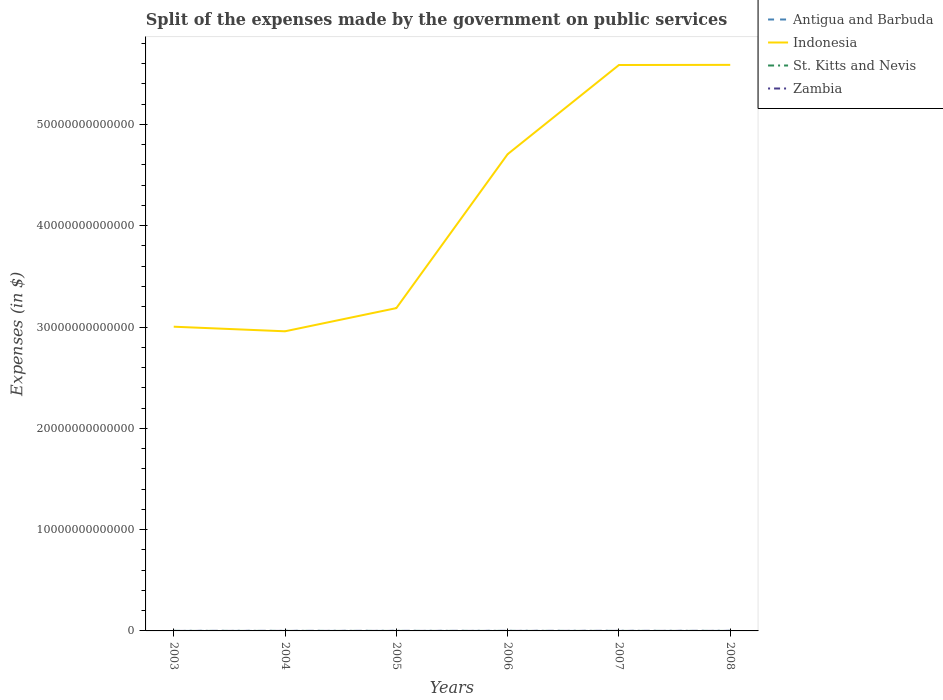Does the line corresponding to Antigua and Barbuda intersect with the line corresponding to Indonesia?
Keep it short and to the point. No. Across all years, what is the maximum expenses made by the government on public services in Antigua and Barbuda?
Provide a succinct answer. 9.59e+07. In which year was the expenses made by the government on public services in Indonesia maximum?
Give a very brief answer. 2004. What is the total expenses made by the government on public services in Antigua and Barbuda in the graph?
Keep it short and to the point. -1.63e+07. What is the difference between the highest and the second highest expenses made by the government on public services in Indonesia?
Your answer should be very brief. 2.63e+13. What is the difference between the highest and the lowest expenses made by the government on public services in Indonesia?
Your answer should be very brief. 3. Is the expenses made by the government on public services in Zambia strictly greater than the expenses made by the government on public services in Indonesia over the years?
Your answer should be very brief. Yes. What is the difference between two consecutive major ticks on the Y-axis?
Offer a very short reply. 1.00e+13. Are the values on the major ticks of Y-axis written in scientific E-notation?
Offer a very short reply. No. Does the graph contain any zero values?
Ensure brevity in your answer.  No. Where does the legend appear in the graph?
Make the answer very short. Top right. How many legend labels are there?
Provide a succinct answer. 4. How are the legend labels stacked?
Give a very brief answer. Vertical. What is the title of the graph?
Make the answer very short. Split of the expenses made by the government on public services. What is the label or title of the X-axis?
Make the answer very short. Years. What is the label or title of the Y-axis?
Your answer should be compact. Expenses (in $). What is the Expenses (in $) in Antigua and Barbuda in 2003?
Offer a terse response. 9.59e+07. What is the Expenses (in $) of Indonesia in 2003?
Give a very brief answer. 3.00e+13. What is the Expenses (in $) in St. Kitts and Nevis in 2003?
Give a very brief answer. 7.90e+07. What is the Expenses (in $) in Zambia in 2003?
Provide a succinct answer. 6.77e+08. What is the Expenses (in $) of Antigua and Barbuda in 2004?
Give a very brief answer. 1.10e+08. What is the Expenses (in $) of Indonesia in 2004?
Your answer should be very brief. 2.96e+13. What is the Expenses (in $) in St. Kitts and Nevis in 2004?
Provide a short and direct response. 9.58e+07. What is the Expenses (in $) of Zambia in 2004?
Provide a succinct answer. 8.90e+08. What is the Expenses (in $) in Antigua and Barbuda in 2005?
Offer a very short reply. 1.11e+08. What is the Expenses (in $) in Indonesia in 2005?
Make the answer very short. 3.19e+13. What is the Expenses (in $) in St. Kitts and Nevis in 2005?
Provide a succinct answer. 1.15e+08. What is the Expenses (in $) in Zambia in 2005?
Your response must be concise. 1.87e+09. What is the Expenses (in $) of Antigua and Barbuda in 2006?
Make the answer very short. 1.26e+08. What is the Expenses (in $) in Indonesia in 2006?
Your answer should be compact. 4.71e+13. What is the Expenses (in $) in St. Kitts and Nevis in 2006?
Make the answer very short. 1.29e+08. What is the Expenses (in $) of Zambia in 2006?
Offer a terse response. 2.12e+09. What is the Expenses (in $) in Antigua and Barbuda in 2007?
Give a very brief answer. 1.48e+08. What is the Expenses (in $) of Indonesia in 2007?
Ensure brevity in your answer.  5.59e+13. What is the Expenses (in $) of St. Kitts and Nevis in 2007?
Make the answer very short. 1.40e+08. What is the Expenses (in $) in Zambia in 2007?
Your answer should be very brief. 3.34e+09. What is the Expenses (in $) in Antigua and Barbuda in 2008?
Provide a short and direct response. 1.85e+08. What is the Expenses (in $) of Indonesia in 2008?
Your answer should be compact. 5.59e+13. What is the Expenses (in $) in St. Kitts and Nevis in 2008?
Keep it short and to the point. 1.37e+08. What is the Expenses (in $) in Zambia in 2008?
Ensure brevity in your answer.  3.00e+09. Across all years, what is the maximum Expenses (in $) of Antigua and Barbuda?
Offer a terse response. 1.85e+08. Across all years, what is the maximum Expenses (in $) of Indonesia?
Provide a succinct answer. 5.59e+13. Across all years, what is the maximum Expenses (in $) in St. Kitts and Nevis?
Your answer should be very brief. 1.40e+08. Across all years, what is the maximum Expenses (in $) in Zambia?
Offer a very short reply. 3.34e+09. Across all years, what is the minimum Expenses (in $) in Antigua and Barbuda?
Provide a succinct answer. 9.59e+07. Across all years, what is the minimum Expenses (in $) of Indonesia?
Give a very brief answer. 2.96e+13. Across all years, what is the minimum Expenses (in $) of St. Kitts and Nevis?
Give a very brief answer. 7.90e+07. Across all years, what is the minimum Expenses (in $) in Zambia?
Provide a short and direct response. 6.77e+08. What is the total Expenses (in $) of Antigua and Barbuda in the graph?
Offer a very short reply. 7.76e+08. What is the total Expenses (in $) in Indonesia in the graph?
Your answer should be very brief. 2.50e+14. What is the total Expenses (in $) of St. Kitts and Nevis in the graph?
Keep it short and to the point. 6.96e+08. What is the total Expenses (in $) in Zambia in the graph?
Provide a succinct answer. 1.19e+1. What is the difference between the Expenses (in $) in Antigua and Barbuda in 2003 and that in 2004?
Keep it short and to the point. -1.40e+07. What is the difference between the Expenses (in $) in Indonesia in 2003 and that in 2004?
Your answer should be compact. 4.54e+11. What is the difference between the Expenses (in $) of St. Kitts and Nevis in 2003 and that in 2004?
Your answer should be very brief. -1.68e+07. What is the difference between the Expenses (in $) of Zambia in 2003 and that in 2004?
Offer a terse response. -2.13e+08. What is the difference between the Expenses (in $) of Antigua and Barbuda in 2003 and that in 2005?
Your answer should be very brief. -1.51e+07. What is the difference between the Expenses (in $) in Indonesia in 2003 and that in 2005?
Offer a terse response. -1.83e+12. What is the difference between the Expenses (in $) of St. Kitts and Nevis in 2003 and that in 2005?
Ensure brevity in your answer.  -3.57e+07. What is the difference between the Expenses (in $) of Zambia in 2003 and that in 2005?
Your response must be concise. -1.20e+09. What is the difference between the Expenses (in $) in Antigua and Barbuda in 2003 and that in 2006?
Offer a terse response. -3.03e+07. What is the difference between the Expenses (in $) in Indonesia in 2003 and that in 2006?
Your answer should be compact. -1.70e+13. What is the difference between the Expenses (in $) in St. Kitts and Nevis in 2003 and that in 2006?
Give a very brief answer. -5.04e+07. What is the difference between the Expenses (in $) in Zambia in 2003 and that in 2006?
Your response must be concise. -1.44e+09. What is the difference between the Expenses (in $) of Antigua and Barbuda in 2003 and that in 2007?
Offer a very short reply. -5.17e+07. What is the difference between the Expenses (in $) of Indonesia in 2003 and that in 2007?
Provide a short and direct response. -2.58e+13. What is the difference between the Expenses (in $) in St. Kitts and Nevis in 2003 and that in 2007?
Provide a succinct answer. -6.14e+07. What is the difference between the Expenses (in $) in Zambia in 2003 and that in 2007?
Give a very brief answer. -2.66e+09. What is the difference between the Expenses (in $) of Antigua and Barbuda in 2003 and that in 2008?
Make the answer very short. -8.91e+07. What is the difference between the Expenses (in $) of Indonesia in 2003 and that in 2008?
Make the answer very short. -2.58e+13. What is the difference between the Expenses (in $) of St. Kitts and Nevis in 2003 and that in 2008?
Your response must be concise. -5.82e+07. What is the difference between the Expenses (in $) of Zambia in 2003 and that in 2008?
Your response must be concise. -2.32e+09. What is the difference between the Expenses (in $) of Antigua and Barbuda in 2004 and that in 2005?
Make the answer very short. -1.10e+06. What is the difference between the Expenses (in $) in Indonesia in 2004 and that in 2005?
Make the answer very short. -2.29e+12. What is the difference between the Expenses (in $) of St. Kitts and Nevis in 2004 and that in 2005?
Make the answer very short. -1.89e+07. What is the difference between the Expenses (in $) of Zambia in 2004 and that in 2005?
Your answer should be compact. -9.83e+08. What is the difference between the Expenses (in $) in Antigua and Barbuda in 2004 and that in 2006?
Ensure brevity in your answer.  -1.63e+07. What is the difference between the Expenses (in $) in Indonesia in 2004 and that in 2006?
Offer a terse response. -1.75e+13. What is the difference between the Expenses (in $) of St. Kitts and Nevis in 2004 and that in 2006?
Make the answer very short. -3.36e+07. What is the difference between the Expenses (in $) in Zambia in 2004 and that in 2006?
Your response must be concise. -1.23e+09. What is the difference between the Expenses (in $) in Antigua and Barbuda in 2004 and that in 2007?
Ensure brevity in your answer.  -3.77e+07. What is the difference between the Expenses (in $) of Indonesia in 2004 and that in 2007?
Provide a succinct answer. -2.63e+13. What is the difference between the Expenses (in $) in St. Kitts and Nevis in 2004 and that in 2007?
Provide a short and direct response. -4.46e+07. What is the difference between the Expenses (in $) of Zambia in 2004 and that in 2007?
Ensure brevity in your answer.  -2.45e+09. What is the difference between the Expenses (in $) of Antigua and Barbuda in 2004 and that in 2008?
Ensure brevity in your answer.  -7.51e+07. What is the difference between the Expenses (in $) in Indonesia in 2004 and that in 2008?
Provide a succinct answer. -2.63e+13. What is the difference between the Expenses (in $) in St. Kitts and Nevis in 2004 and that in 2008?
Provide a succinct answer. -4.14e+07. What is the difference between the Expenses (in $) of Zambia in 2004 and that in 2008?
Keep it short and to the point. -2.11e+09. What is the difference between the Expenses (in $) in Antigua and Barbuda in 2005 and that in 2006?
Give a very brief answer. -1.52e+07. What is the difference between the Expenses (in $) of Indonesia in 2005 and that in 2006?
Your answer should be compact. -1.52e+13. What is the difference between the Expenses (in $) of St. Kitts and Nevis in 2005 and that in 2006?
Provide a succinct answer. -1.47e+07. What is the difference between the Expenses (in $) of Zambia in 2005 and that in 2006?
Give a very brief answer. -2.44e+08. What is the difference between the Expenses (in $) in Antigua and Barbuda in 2005 and that in 2007?
Your answer should be compact. -3.66e+07. What is the difference between the Expenses (in $) in Indonesia in 2005 and that in 2007?
Keep it short and to the point. -2.40e+13. What is the difference between the Expenses (in $) in St. Kitts and Nevis in 2005 and that in 2007?
Offer a very short reply. -2.57e+07. What is the difference between the Expenses (in $) of Zambia in 2005 and that in 2007?
Offer a very short reply. -1.47e+09. What is the difference between the Expenses (in $) in Antigua and Barbuda in 2005 and that in 2008?
Provide a short and direct response. -7.40e+07. What is the difference between the Expenses (in $) of Indonesia in 2005 and that in 2008?
Provide a succinct answer. -2.40e+13. What is the difference between the Expenses (in $) in St. Kitts and Nevis in 2005 and that in 2008?
Your answer should be compact. -2.25e+07. What is the difference between the Expenses (in $) in Zambia in 2005 and that in 2008?
Your answer should be very brief. -1.13e+09. What is the difference between the Expenses (in $) of Antigua and Barbuda in 2006 and that in 2007?
Give a very brief answer. -2.14e+07. What is the difference between the Expenses (in $) of Indonesia in 2006 and that in 2007?
Your response must be concise. -8.80e+12. What is the difference between the Expenses (in $) of St. Kitts and Nevis in 2006 and that in 2007?
Your answer should be compact. -1.10e+07. What is the difference between the Expenses (in $) of Zambia in 2006 and that in 2007?
Your answer should be very brief. -1.22e+09. What is the difference between the Expenses (in $) of Antigua and Barbuda in 2006 and that in 2008?
Offer a very short reply. -5.88e+07. What is the difference between the Expenses (in $) of Indonesia in 2006 and that in 2008?
Offer a very short reply. -8.81e+12. What is the difference between the Expenses (in $) of St. Kitts and Nevis in 2006 and that in 2008?
Give a very brief answer. -7.80e+06. What is the difference between the Expenses (in $) of Zambia in 2006 and that in 2008?
Offer a terse response. -8.83e+08. What is the difference between the Expenses (in $) in Antigua and Barbuda in 2007 and that in 2008?
Provide a succinct answer. -3.74e+07. What is the difference between the Expenses (in $) of Indonesia in 2007 and that in 2008?
Provide a short and direct response. -1.24e+1. What is the difference between the Expenses (in $) of St. Kitts and Nevis in 2007 and that in 2008?
Give a very brief answer. 3.20e+06. What is the difference between the Expenses (in $) in Zambia in 2007 and that in 2008?
Make the answer very short. 3.41e+08. What is the difference between the Expenses (in $) in Antigua and Barbuda in 2003 and the Expenses (in $) in Indonesia in 2004?
Your answer should be very brief. -2.96e+13. What is the difference between the Expenses (in $) of Antigua and Barbuda in 2003 and the Expenses (in $) of Zambia in 2004?
Your response must be concise. -7.94e+08. What is the difference between the Expenses (in $) in Indonesia in 2003 and the Expenses (in $) in St. Kitts and Nevis in 2004?
Offer a terse response. 3.00e+13. What is the difference between the Expenses (in $) of Indonesia in 2003 and the Expenses (in $) of Zambia in 2004?
Offer a terse response. 3.00e+13. What is the difference between the Expenses (in $) of St. Kitts and Nevis in 2003 and the Expenses (in $) of Zambia in 2004?
Give a very brief answer. -8.11e+08. What is the difference between the Expenses (in $) in Antigua and Barbuda in 2003 and the Expenses (in $) in Indonesia in 2005?
Your answer should be compact. -3.19e+13. What is the difference between the Expenses (in $) in Antigua and Barbuda in 2003 and the Expenses (in $) in St. Kitts and Nevis in 2005?
Make the answer very short. -1.88e+07. What is the difference between the Expenses (in $) in Antigua and Barbuda in 2003 and the Expenses (in $) in Zambia in 2005?
Offer a terse response. -1.78e+09. What is the difference between the Expenses (in $) of Indonesia in 2003 and the Expenses (in $) of St. Kitts and Nevis in 2005?
Ensure brevity in your answer.  3.00e+13. What is the difference between the Expenses (in $) in Indonesia in 2003 and the Expenses (in $) in Zambia in 2005?
Provide a succinct answer. 3.00e+13. What is the difference between the Expenses (in $) of St. Kitts and Nevis in 2003 and the Expenses (in $) of Zambia in 2005?
Provide a succinct answer. -1.79e+09. What is the difference between the Expenses (in $) in Antigua and Barbuda in 2003 and the Expenses (in $) in Indonesia in 2006?
Make the answer very short. -4.71e+13. What is the difference between the Expenses (in $) in Antigua and Barbuda in 2003 and the Expenses (in $) in St. Kitts and Nevis in 2006?
Keep it short and to the point. -3.35e+07. What is the difference between the Expenses (in $) of Antigua and Barbuda in 2003 and the Expenses (in $) of Zambia in 2006?
Give a very brief answer. -2.02e+09. What is the difference between the Expenses (in $) of Indonesia in 2003 and the Expenses (in $) of St. Kitts and Nevis in 2006?
Your answer should be very brief. 3.00e+13. What is the difference between the Expenses (in $) in Indonesia in 2003 and the Expenses (in $) in Zambia in 2006?
Make the answer very short. 3.00e+13. What is the difference between the Expenses (in $) of St. Kitts and Nevis in 2003 and the Expenses (in $) of Zambia in 2006?
Keep it short and to the point. -2.04e+09. What is the difference between the Expenses (in $) of Antigua and Barbuda in 2003 and the Expenses (in $) of Indonesia in 2007?
Your answer should be very brief. -5.59e+13. What is the difference between the Expenses (in $) in Antigua and Barbuda in 2003 and the Expenses (in $) in St. Kitts and Nevis in 2007?
Provide a succinct answer. -4.45e+07. What is the difference between the Expenses (in $) of Antigua and Barbuda in 2003 and the Expenses (in $) of Zambia in 2007?
Your answer should be very brief. -3.25e+09. What is the difference between the Expenses (in $) in Indonesia in 2003 and the Expenses (in $) in St. Kitts and Nevis in 2007?
Offer a terse response. 3.00e+13. What is the difference between the Expenses (in $) of Indonesia in 2003 and the Expenses (in $) of Zambia in 2007?
Keep it short and to the point. 3.00e+13. What is the difference between the Expenses (in $) of St. Kitts and Nevis in 2003 and the Expenses (in $) of Zambia in 2007?
Offer a terse response. -3.26e+09. What is the difference between the Expenses (in $) in Antigua and Barbuda in 2003 and the Expenses (in $) in Indonesia in 2008?
Offer a terse response. -5.59e+13. What is the difference between the Expenses (in $) in Antigua and Barbuda in 2003 and the Expenses (in $) in St. Kitts and Nevis in 2008?
Make the answer very short. -4.13e+07. What is the difference between the Expenses (in $) of Antigua and Barbuda in 2003 and the Expenses (in $) of Zambia in 2008?
Your answer should be compact. -2.90e+09. What is the difference between the Expenses (in $) in Indonesia in 2003 and the Expenses (in $) in St. Kitts and Nevis in 2008?
Your response must be concise. 3.00e+13. What is the difference between the Expenses (in $) of Indonesia in 2003 and the Expenses (in $) of Zambia in 2008?
Your answer should be very brief. 3.00e+13. What is the difference between the Expenses (in $) of St. Kitts and Nevis in 2003 and the Expenses (in $) of Zambia in 2008?
Provide a succinct answer. -2.92e+09. What is the difference between the Expenses (in $) of Antigua and Barbuda in 2004 and the Expenses (in $) of Indonesia in 2005?
Provide a succinct answer. -3.19e+13. What is the difference between the Expenses (in $) in Antigua and Barbuda in 2004 and the Expenses (in $) in St. Kitts and Nevis in 2005?
Offer a terse response. -4.80e+06. What is the difference between the Expenses (in $) of Antigua and Barbuda in 2004 and the Expenses (in $) of Zambia in 2005?
Your answer should be very brief. -1.76e+09. What is the difference between the Expenses (in $) of Indonesia in 2004 and the Expenses (in $) of St. Kitts and Nevis in 2005?
Your response must be concise. 2.96e+13. What is the difference between the Expenses (in $) of Indonesia in 2004 and the Expenses (in $) of Zambia in 2005?
Give a very brief answer. 2.96e+13. What is the difference between the Expenses (in $) of St. Kitts and Nevis in 2004 and the Expenses (in $) of Zambia in 2005?
Offer a terse response. -1.78e+09. What is the difference between the Expenses (in $) in Antigua and Barbuda in 2004 and the Expenses (in $) in Indonesia in 2006?
Your answer should be very brief. -4.71e+13. What is the difference between the Expenses (in $) in Antigua and Barbuda in 2004 and the Expenses (in $) in St. Kitts and Nevis in 2006?
Provide a short and direct response. -1.95e+07. What is the difference between the Expenses (in $) of Antigua and Barbuda in 2004 and the Expenses (in $) of Zambia in 2006?
Your response must be concise. -2.01e+09. What is the difference between the Expenses (in $) in Indonesia in 2004 and the Expenses (in $) in St. Kitts and Nevis in 2006?
Offer a terse response. 2.96e+13. What is the difference between the Expenses (in $) of Indonesia in 2004 and the Expenses (in $) of Zambia in 2006?
Make the answer very short. 2.96e+13. What is the difference between the Expenses (in $) in St. Kitts and Nevis in 2004 and the Expenses (in $) in Zambia in 2006?
Make the answer very short. -2.02e+09. What is the difference between the Expenses (in $) of Antigua and Barbuda in 2004 and the Expenses (in $) of Indonesia in 2007?
Your response must be concise. -5.59e+13. What is the difference between the Expenses (in $) in Antigua and Barbuda in 2004 and the Expenses (in $) in St. Kitts and Nevis in 2007?
Provide a short and direct response. -3.05e+07. What is the difference between the Expenses (in $) of Antigua and Barbuda in 2004 and the Expenses (in $) of Zambia in 2007?
Your response must be concise. -3.23e+09. What is the difference between the Expenses (in $) of Indonesia in 2004 and the Expenses (in $) of St. Kitts and Nevis in 2007?
Your answer should be very brief. 2.96e+13. What is the difference between the Expenses (in $) in Indonesia in 2004 and the Expenses (in $) in Zambia in 2007?
Provide a short and direct response. 2.96e+13. What is the difference between the Expenses (in $) of St. Kitts and Nevis in 2004 and the Expenses (in $) of Zambia in 2007?
Offer a terse response. -3.25e+09. What is the difference between the Expenses (in $) of Antigua and Barbuda in 2004 and the Expenses (in $) of Indonesia in 2008?
Offer a very short reply. -5.59e+13. What is the difference between the Expenses (in $) of Antigua and Barbuda in 2004 and the Expenses (in $) of St. Kitts and Nevis in 2008?
Your answer should be compact. -2.73e+07. What is the difference between the Expenses (in $) in Antigua and Barbuda in 2004 and the Expenses (in $) in Zambia in 2008?
Provide a short and direct response. -2.89e+09. What is the difference between the Expenses (in $) in Indonesia in 2004 and the Expenses (in $) in St. Kitts and Nevis in 2008?
Offer a very short reply. 2.96e+13. What is the difference between the Expenses (in $) in Indonesia in 2004 and the Expenses (in $) in Zambia in 2008?
Your response must be concise. 2.96e+13. What is the difference between the Expenses (in $) of St. Kitts and Nevis in 2004 and the Expenses (in $) of Zambia in 2008?
Provide a short and direct response. -2.90e+09. What is the difference between the Expenses (in $) in Antigua and Barbuda in 2005 and the Expenses (in $) in Indonesia in 2006?
Give a very brief answer. -4.71e+13. What is the difference between the Expenses (in $) of Antigua and Barbuda in 2005 and the Expenses (in $) of St. Kitts and Nevis in 2006?
Your response must be concise. -1.84e+07. What is the difference between the Expenses (in $) of Antigua and Barbuda in 2005 and the Expenses (in $) of Zambia in 2006?
Provide a short and direct response. -2.01e+09. What is the difference between the Expenses (in $) in Indonesia in 2005 and the Expenses (in $) in St. Kitts and Nevis in 2006?
Keep it short and to the point. 3.19e+13. What is the difference between the Expenses (in $) in Indonesia in 2005 and the Expenses (in $) in Zambia in 2006?
Give a very brief answer. 3.19e+13. What is the difference between the Expenses (in $) of St. Kitts and Nevis in 2005 and the Expenses (in $) of Zambia in 2006?
Your response must be concise. -2.00e+09. What is the difference between the Expenses (in $) of Antigua and Barbuda in 2005 and the Expenses (in $) of Indonesia in 2007?
Offer a terse response. -5.59e+13. What is the difference between the Expenses (in $) in Antigua and Barbuda in 2005 and the Expenses (in $) in St. Kitts and Nevis in 2007?
Offer a terse response. -2.94e+07. What is the difference between the Expenses (in $) of Antigua and Barbuda in 2005 and the Expenses (in $) of Zambia in 2007?
Make the answer very short. -3.23e+09. What is the difference between the Expenses (in $) of Indonesia in 2005 and the Expenses (in $) of St. Kitts and Nevis in 2007?
Keep it short and to the point. 3.19e+13. What is the difference between the Expenses (in $) in Indonesia in 2005 and the Expenses (in $) in Zambia in 2007?
Your answer should be compact. 3.19e+13. What is the difference between the Expenses (in $) of St. Kitts and Nevis in 2005 and the Expenses (in $) of Zambia in 2007?
Your answer should be very brief. -3.23e+09. What is the difference between the Expenses (in $) in Antigua and Barbuda in 2005 and the Expenses (in $) in Indonesia in 2008?
Make the answer very short. -5.59e+13. What is the difference between the Expenses (in $) of Antigua and Barbuda in 2005 and the Expenses (in $) of St. Kitts and Nevis in 2008?
Provide a short and direct response. -2.62e+07. What is the difference between the Expenses (in $) of Antigua and Barbuda in 2005 and the Expenses (in $) of Zambia in 2008?
Provide a succinct answer. -2.89e+09. What is the difference between the Expenses (in $) in Indonesia in 2005 and the Expenses (in $) in St. Kitts and Nevis in 2008?
Your answer should be compact. 3.19e+13. What is the difference between the Expenses (in $) of Indonesia in 2005 and the Expenses (in $) of Zambia in 2008?
Provide a short and direct response. 3.19e+13. What is the difference between the Expenses (in $) in St. Kitts and Nevis in 2005 and the Expenses (in $) in Zambia in 2008?
Offer a terse response. -2.89e+09. What is the difference between the Expenses (in $) of Antigua and Barbuda in 2006 and the Expenses (in $) of Indonesia in 2007?
Your answer should be compact. -5.59e+13. What is the difference between the Expenses (in $) of Antigua and Barbuda in 2006 and the Expenses (in $) of St. Kitts and Nevis in 2007?
Ensure brevity in your answer.  -1.42e+07. What is the difference between the Expenses (in $) of Antigua and Barbuda in 2006 and the Expenses (in $) of Zambia in 2007?
Your answer should be compact. -3.21e+09. What is the difference between the Expenses (in $) of Indonesia in 2006 and the Expenses (in $) of St. Kitts and Nevis in 2007?
Offer a very short reply. 4.71e+13. What is the difference between the Expenses (in $) of Indonesia in 2006 and the Expenses (in $) of Zambia in 2007?
Ensure brevity in your answer.  4.71e+13. What is the difference between the Expenses (in $) of St. Kitts and Nevis in 2006 and the Expenses (in $) of Zambia in 2007?
Ensure brevity in your answer.  -3.21e+09. What is the difference between the Expenses (in $) of Antigua and Barbuda in 2006 and the Expenses (in $) of Indonesia in 2008?
Make the answer very short. -5.59e+13. What is the difference between the Expenses (in $) of Antigua and Barbuda in 2006 and the Expenses (in $) of St. Kitts and Nevis in 2008?
Your answer should be very brief. -1.10e+07. What is the difference between the Expenses (in $) of Antigua and Barbuda in 2006 and the Expenses (in $) of Zambia in 2008?
Your answer should be very brief. -2.87e+09. What is the difference between the Expenses (in $) in Indonesia in 2006 and the Expenses (in $) in St. Kitts and Nevis in 2008?
Give a very brief answer. 4.71e+13. What is the difference between the Expenses (in $) of Indonesia in 2006 and the Expenses (in $) of Zambia in 2008?
Your answer should be very brief. 4.71e+13. What is the difference between the Expenses (in $) in St. Kitts and Nevis in 2006 and the Expenses (in $) in Zambia in 2008?
Your answer should be compact. -2.87e+09. What is the difference between the Expenses (in $) in Antigua and Barbuda in 2007 and the Expenses (in $) in Indonesia in 2008?
Provide a succinct answer. -5.59e+13. What is the difference between the Expenses (in $) of Antigua and Barbuda in 2007 and the Expenses (in $) of St. Kitts and Nevis in 2008?
Ensure brevity in your answer.  1.04e+07. What is the difference between the Expenses (in $) in Antigua and Barbuda in 2007 and the Expenses (in $) in Zambia in 2008?
Keep it short and to the point. -2.85e+09. What is the difference between the Expenses (in $) in Indonesia in 2007 and the Expenses (in $) in St. Kitts and Nevis in 2008?
Make the answer very short. 5.59e+13. What is the difference between the Expenses (in $) of Indonesia in 2007 and the Expenses (in $) of Zambia in 2008?
Your response must be concise. 5.59e+13. What is the difference between the Expenses (in $) of St. Kitts and Nevis in 2007 and the Expenses (in $) of Zambia in 2008?
Your answer should be compact. -2.86e+09. What is the average Expenses (in $) in Antigua and Barbuda per year?
Provide a succinct answer. 1.29e+08. What is the average Expenses (in $) in Indonesia per year?
Offer a terse response. 4.17e+13. What is the average Expenses (in $) in St. Kitts and Nevis per year?
Offer a terse response. 1.16e+08. What is the average Expenses (in $) of Zambia per year?
Provide a short and direct response. 1.98e+09. In the year 2003, what is the difference between the Expenses (in $) of Antigua and Barbuda and Expenses (in $) of Indonesia?
Give a very brief answer. -3.00e+13. In the year 2003, what is the difference between the Expenses (in $) of Antigua and Barbuda and Expenses (in $) of St. Kitts and Nevis?
Offer a very short reply. 1.69e+07. In the year 2003, what is the difference between the Expenses (in $) of Antigua and Barbuda and Expenses (in $) of Zambia?
Offer a terse response. -5.81e+08. In the year 2003, what is the difference between the Expenses (in $) of Indonesia and Expenses (in $) of St. Kitts and Nevis?
Offer a very short reply. 3.00e+13. In the year 2003, what is the difference between the Expenses (in $) of Indonesia and Expenses (in $) of Zambia?
Ensure brevity in your answer.  3.00e+13. In the year 2003, what is the difference between the Expenses (in $) of St. Kitts and Nevis and Expenses (in $) of Zambia?
Offer a terse response. -5.98e+08. In the year 2004, what is the difference between the Expenses (in $) of Antigua and Barbuda and Expenses (in $) of Indonesia?
Offer a terse response. -2.96e+13. In the year 2004, what is the difference between the Expenses (in $) in Antigua and Barbuda and Expenses (in $) in St. Kitts and Nevis?
Make the answer very short. 1.41e+07. In the year 2004, what is the difference between the Expenses (in $) of Antigua and Barbuda and Expenses (in $) of Zambia?
Your answer should be very brief. -7.80e+08. In the year 2004, what is the difference between the Expenses (in $) of Indonesia and Expenses (in $) of St. Kitts and Nevis?
Your response must be concise. 2.96e+13. In the year 2004, what is the difference between the Expenses (in $) of Indonesia and Expenses (in $) of Zambia?
Your response must be concise. 2.96e+13. In the year 2004, what is the difference between the Expenses (in $) in St. Kitts and Nevis and Expenses (in $) in Zambia?
Ensure brevity in your answer.  -7.94e+08. In the year 2005, what is the difference between the Expenses (in $) in Antigua and Barbuda and Expenses (in $) in Indonesia?
Keep it short and to the point. -3.19e+13. In the year 2005, what is the difference between the Expenses (in $) in Antigua and Barbuda and Expenses (in $) in St. Kitts and Nevis?
Your answer should be compact. -3.70e+06. In the year 2005, what is the difference between the Expenses (in $) of Antigua and Barbuda and Expenses (in $) of Zambia?
Make the answer very short. -1.76e+09. In the year 2005, what is the difference between the Expenses (in $) in Indonesia and Expenses (in $) in St. Kitts and Nevis?
Offer a terse response. 3.19e+13. In the year 2005, what is the difference between the Expenses (in $) in Indonesia and Expenses (in $) in Zambia?
Ensure brevity in your answer.  3.19e+13. In the year 2005, what is the difference between the Expenses (in $) in St. Kitts and Nevis and Expenses (in $) in Zambia?
Your answer should be very brief. -1.76e+09. In the year 2006, what is the difference between the Expenses (in $) of Antigua and Barbuda and Expenses (in $) of Indonesia?
Your response must be concise. -4.71e+13. In the year 2006, what is the difference between the Expenses (in $) in Antigua and Barbuda and Expenses (in $) in St. Kitts and Nevis?
Your answer should be compact. -3.20e+06. In the year 2006, what is the difference between the Expenses (in $) of Antigua and Barbuda and Expenses (in $) of Zambia?
Your response must be concise. -1.99e+09. In the year 2006, what is the difference between the Expenses (in $) in Indonesia and Expenses (in $) in St. Kitts and Nevis?
Offer a very short reply. 4.71e+13. In the year 2006, what is the difference between the Expenses (in $) in Indonesia and Expenses (in $) in Zambia?
Offer a terse response. 4.71e+13. In the year 2006, what is the difference between the Expenses (in $) of St. Kitts and Nevis and Expenses (in $) of Zambia?
Keep it short and to the point. -1.99e+09. In the year 2007, what is the difference between the Expenses (in $) of Antigua and Barbuda and Expenses (in $) of Indonesia?
Your answer should be very brief. -5.59e+13. In the year 2007, what is the difference between the Expenses (in $) of Antigua and Barbuda and Expenses (in $) of St. Kitts and Nevis?
Provide a short and direct response. 7.20e+06. In the year 2007, what is the difference between the Expenses (in $) of Antigua and Barbuda and Expenses (in $) of Zambia?
Ensure brevity in your answer.  -3.19e+09. In the year 2007, what is the difference between the Expenses (in $) in Indonesia and Expenses (in $) in St. Kitts and Nevis?
Offer a very short reply. 5.59e+13. In the year 2007, what is the difference between the Expenses (in $) of Indonesia and Expenses (in $) of Zambia?
Your response must be concise. 5.59e+13. In the year 2007, what is the difference between the Expenses (in $) of St. Kitts and Nevis and Expenses (in $) of Zambia?
Provide a succinct answer. -3.20e+09. In the year 2008, what is the difference between the Expenses (in $) of Antigua and Barbuda and Expenses (in $) of Indonesia?
Offer a very short reply. -5.59e+13. In the year 2008, what is the difference between the Expenses (in $) of Antigua and Barbuda and Expenses (in $) of St. Kitts and Nevis?
Offer a very short reply. 4.78e+07. In the year 2008, what is the difference between the Expenses (in $) of Antigua and Barbuda and Expenses (in $) of Zambia?
Provide a short and direct response. -2.82e+09. In the year 2008, what is the difference between the Expenses (in $) in Indonesia and Expenses (in $) in St. Kitts and Nevis?
Your answer should be very brief. 5.59e+13. In the year 2008, what is the difference between the Expenses (in $) of Indonesia and Expenses (in $) of Zambia?
Your answer should be very brief. 5.59e+13. In the year 2008, what is the difference between the Expenses (in $) in St. Kitts and Nevis and Expenses (in $) in Zambia?
Ensure brevity in your answer.  -2.86e+09. What is the ratio of the Expenses (in $) of Antigua and Barbuda in 2003 to that in 2004?
Ensure brevity in your answer.  0.87. What is the ratio of the Expenses (in $) in Indonesia in 2003 to that in 2004?
Make the answer very short. 1.02. What is the ratio of the Expenses (in $) of St. Kitts and Nevis in 2003 to that in 2004?
Make the answer very short. 0.82. What is the ratio of the Expenses (in $) in Zambia in 2003 to that in 2004?
Give a very brief answer. 0.76. What is the ratio of the Expenses (in $) of Antigua and Barbuda in 2003 to that in 2005?
Offer a very short reply. 0.86. What is the ratio of the Expenses (in $) in Indonesia in 2003 to that in 2005?
Provide a short and direct response. 0.94. What is the ratio of the Expenses (in $) in St. Kitts and Nevis in 2003 to that in 2005?
Offer a very short reply. 0.69. What is the ratio of the Expenses (in $) of Zambia in 2003 to that in 2005?
Give a very brief answer. 0.36. What is the ratio of the Expenses (in $) in Antigua and Barbuda in 2003 to that in 2006?
Your answer should be very brief. 0.76. What is the ratio of the Expenses (in $) of Indonesia in 2003 to that in 2006?
Make the answer very short. 0.64. What is the ratio of the Expenses (in $) of St. Kitts and Nevis in 2003 to that in 2006?
Give a very brief answer. 0.61. What is the ratio of the Expenses (in $) in Zambia in 2003 to that in 2006?
Keep it short and to the point. 0.32. What is the ratio of the Expenses (in $) in Antigua and Barbuda in 2003 to that in 2007?
Ensure brevity in your answer.  0.65. What is the ratio of the Expenses (in $) of Indonesia in 2003 to that in 2007?
Your answer should be very brief. 0.54. What is the ratio of the Expenses (in $) of St. Kitts and Nevis in 2003 to that in 2007?
Your answer should be very brief. 0.56. What is the ratio of the Expenses (in $) in Zambia in 2003 to that in 2007?
Provide a succinct answer. 0.2. What is the ratio of the Expenses (in $) in Antigua and Barbuda in 2003 to that in 2008?
Make the answer very short. 0.52. What is the ratio of the Expenses (in $) of Indonesia in 2003 to that in 2008?
Your answer should be compact. 0.54. What is the ratio of the Expenses (in $) of St. Kitts and Nevis in 2003 to that in 2008?
Give a very brief answer. 0.58. What is the ratio of the Expenses (in $) in Zambia in 2003 to that in 2008?
Offer a terse response. 0.23. What is the ratio of the Expenses (in $) of Antigua and Barbuda in 2004 to that in 2005?
Your answer should be compact. 0.99. What is the ratio of the Expenses (in $) of Indonesia in 2004 to that in 2005?
Offer a very short reply. 0.93. What is the ratio of the Expenses (in $) in St. Kitts and Nevis in 2004 to that in 2005?
Give a very brief answer. 0.84. What is the ratio of the Expenses (in $) in Zambia in 2004 to that in 2005?
Offer a very short reply. 0.48. What is the ratio of the Expenses (in $) of Antigua and Barbuda in 2004 to that in 2006?
Provide a short and direct response. 0.87. What is the ratio of the Expenses (in $) in Indonesia in 2004 to that in 2006?
Your answer should be compact. 0.63. What is the ratio of the Expenses (in $) in St. Kitts and Nevis in 2004 to that in 2006?
Offer a very short reply. 0.74. What is the ratio of the Expenses (in $) in Zambia in 2004 to that in 2006?
Give a very brief answer. 0.42. What is the ratio of the Expenses (in $) in Antigua and Barbuda in 2004 to that in 2007?
Provide a succinct answer. 0.74. What is the ratio of the Expenses (in $) of Indonesia in 2004 to that in 2007?
Your answer should be compact. 0.53. What is the ratio of the Expenses (in $) in St. Kitts and Nevis in 2004 to that in 2007?
Your response must be concise. 0.68. What is the ratio of the Expenses (in $) in Zambia in 2004 to that in 2007?
Your answer should be compact. 0.27. What is the ratio of the Expenses (in $) of Antigua and Barbuda in 2004 to that in 2008?
Your answer should be very brief. 0.59. What is the ratio of the Expenses (in $) of Indonesia in 2004 to that in 2008?
Keep it short and to the point. 0.53. What is the ratio of the Expenses (in $) in St. Kitts and Nevis in 2004 to that in 2008?
Give a very brief answer. 0.7. What is the ratio of the Expenses (in $) of Zambia in 2004 to that in 2008?
Ensure brevity in your answer.  0.3. What is the ratio of the Expenses (in $) in Antigua and Barbuda in 2005 to that in 2006?
Provide a succinct answer. 0.88. What is the ratio of the Expenses (in $) of Indonesia in 2005 to that in 2006?
Make the answer very short. 0.68. What is the ratio of the Expenses (in $) of St. Kitts and Nevis in 2005 to that in 2006?
Make the answer very short. 0.89. What is the ratio of the Expenses (in $) of Zambia in 2005 to that in 2006?
Keep it short and to the point. 0.88. What is the ratio of the Expenses (in $) in Antigua and Barbuda in 2005 to that in 2007?
Provide a succinct answer. 0.75. What is the ratio of the Expenses (in $) in Indonesia in 2005 to that in 2007?
Give a very brief answer. 0.57. What is the ratio of the Expenses (in $) of St. Kitts and Nevis in 2005 to that in 2007?
Keep it short and to the point. 0.82. What is the ratio of the Expenses (in $) of Zambia in 2005 to that in 2007?
Make the answer very short. 0.56. What is the ratio of the Expenses (in $) in Indonesia in 2005 to that in 2008?
Offer a very short reply. 0.57. What is the ratio of the Expenses (in $) in St. Kitts and Nevis in 2005 to that in 2008?
Provide a short and direct response. 0.84. What is the ratio of the Expenses (in $) of Zambia in 2005 to that in 2008?
Provide a short and direct response. 0.62. What is the ratio of the Expenses (in $) in Antigua and Barbuda in 2006 to that in 2007?
Your answer should be compact. 0.85. What is the ratio of the Expenses (in $) in Indonesia in 2006 to that in 2007?
Give a very brief answer. 0.84. What is the ratio of the Expenses (in $) of St. Kitts and Nevis in 2006 to that in 2007?
Keep it short and to the point. 0.92. What is the ratio of the Expenses (in $) of Zambia in 2006 to that in 2007?
Ensure brevity in your answer.  0.63. What is the ratio of the Expenses (in $) in Antigua and Barbuda in 2006 to that in 2008?
Keep it short and to the point. 0.68. What is the ratio of the Expenses (in $) in Indonesia in 2006 to that in 2008?
Offer a very short reply. 0.84. What is the ratio of the Expenses (in $) in St. Kitts and Nevis in 2006 to that in 2008?
Keep it short and to the point. 0.94. What is the ratio of the Expenses (in $) of Zambia in 2006 to that in 2008?
Provide a short and direct response. 0.71. What is the ratio of the Expenses (in $) in Antigua and Barbuda in 2007 to that in 2008?
Ensure brevity in your answer.  0.8. What is the ratio of the Expenses (in $) in St. Kitts and Nevis in 2007 to that in 2008?
Offer a terse response. 1.02. What is the ratio of the Expenses (in $) in Zambia in 2007 to that in 2008?
Ensure brevity in your answer.  1.11. What is the difference between the highest and the second highest Expenses (in $) in Antigua and Barbuda?
Your response must be concise. 3.74e+07. What is the difference between the highest and the second highest Expenses (in $) of Indonesia?
Offer a terse response. 1.24e+1. What is the difference between the highest and the second highest Expenses (in $) in St. Kitts and Nevis?
Your answer should be compact. 3.20e+06. What is the difference between the highest and the second highest Expenses (in $) of Zambia?
Give a very brief answer. 3.41e+08. What is the difference between the highest and the lowest Expenses (in $) of Antigua and Barbuda?
Ensure brevity in your answer.  8.91e+07. What is the difference between the highest and the lowest Expenses (in $) of Indonesia?
Your answer should be very brief. 2.63e+13. What is the difference between the highest and the lowest Expenses (in $) in St. Kitts and Nevis?
Make the answer very short. 6.14e+07. What is the difference between the highest and the lowest Expenses (in $) of Zambia?
Keep it short and to the point. 2.66e+09. 